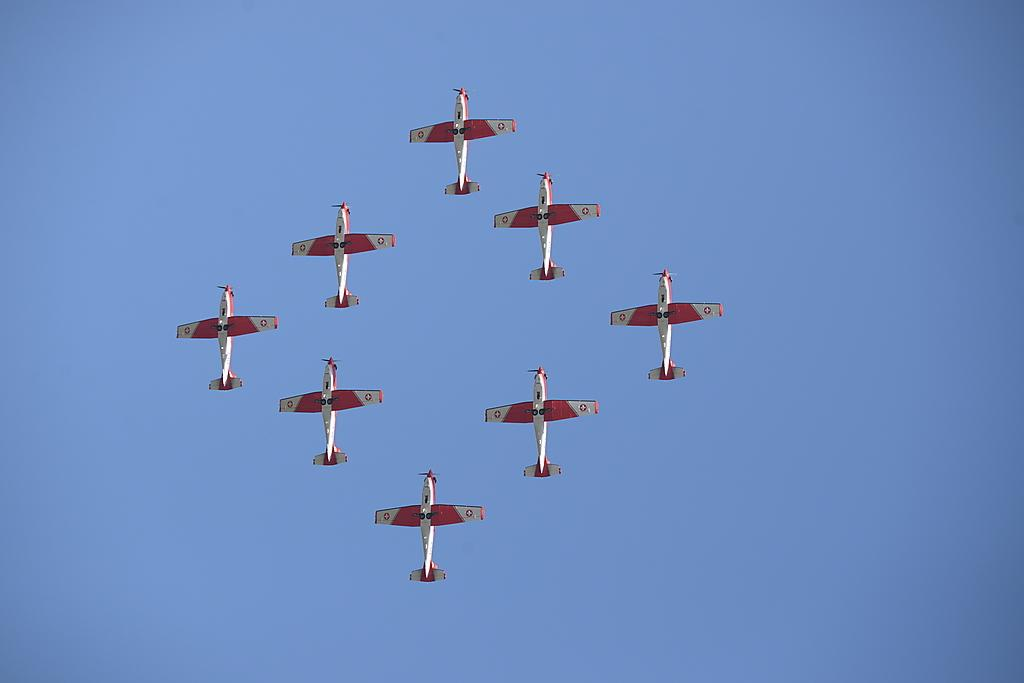What is the main subject of the image? The main subject of the image is airplanes. What colors are the airplanes in the image? The airplanes are in red and white color. Where are the airplanes located in the image? The airplanes are in the center of the image. What can be seen in the background of the image? The sky is visible in the background of the image. What type of volleyball game is being played in the image? There is no volleyball game present in the image; it features airplanes in red and white color. Can you describe the driving conditions in the image? There is no driving present in the image; it features airplanes in the center of the image with a visible sky in the background. 